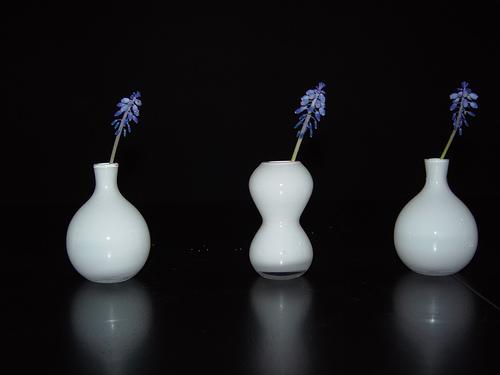What do the flowers smell like?
Write a very short answer. Lavender. Why is the vase in the middle shaped differently?
Keep it brief. Design. How many colors are in this photo?
Quick response, please. 2. Is the middle vase completely white?
Answer briefly. No. 